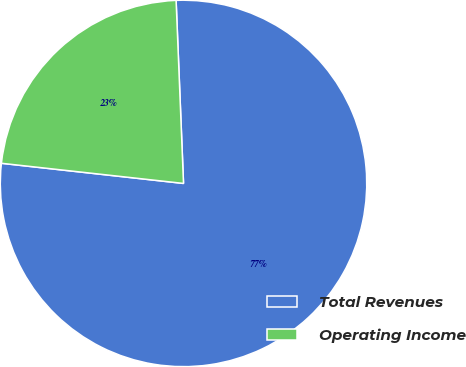Convert chart to OTSL. <chart><loc_0><loc_0><loc_500><loc_500><pie_chart><fcel>Total Revenues<fcel>Operating Income<nl><fcel>77.4%<fcel>22.6%<nl></chart> 